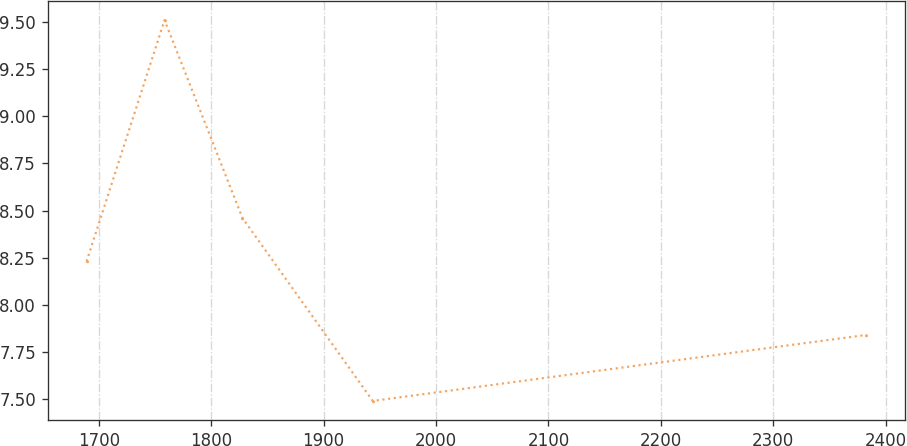Convert chart to OTSL. <chart><loc_0><loc_0><loc_500><loc_500><line_chart><ecel><fcel>Unnamed: 1<nl><fcel>1689.2<fcel>8.23<nl><fcel>1758.54<fcel>9.51<nl><fcel>1827.88<fcel>8.46<nl><fcel>1943.76<fcel>7.49<nl><fcel>2382.55<fcel>7.84<nl></chart> 